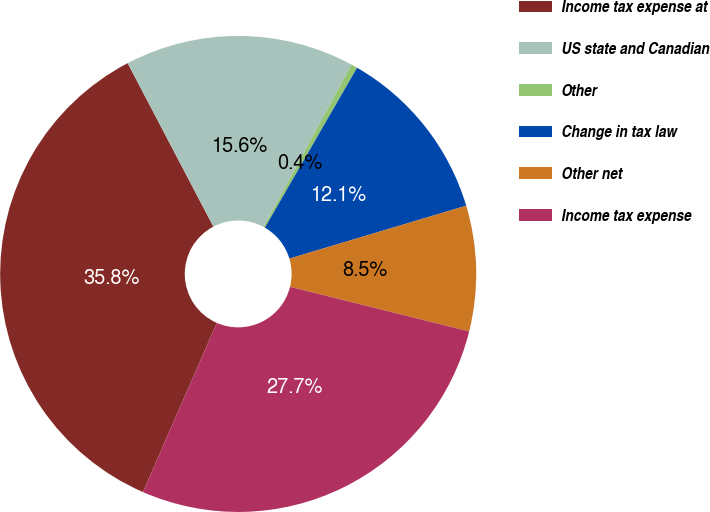<chart> <loc_0><loc_0><loc_500><loc_500><pie_chart><fcel>Income tax expense at<fcel>US state and Canadian<fcel>Other<fcel>Change in tax law<fcel>Other net<fcel>Income tax expense<nl><fcel>35.76%<fcel>15.58%<fcel>0.43%<fcel>12.05%<fcel>8.51%<fcel>27.67%<nl></chart> 